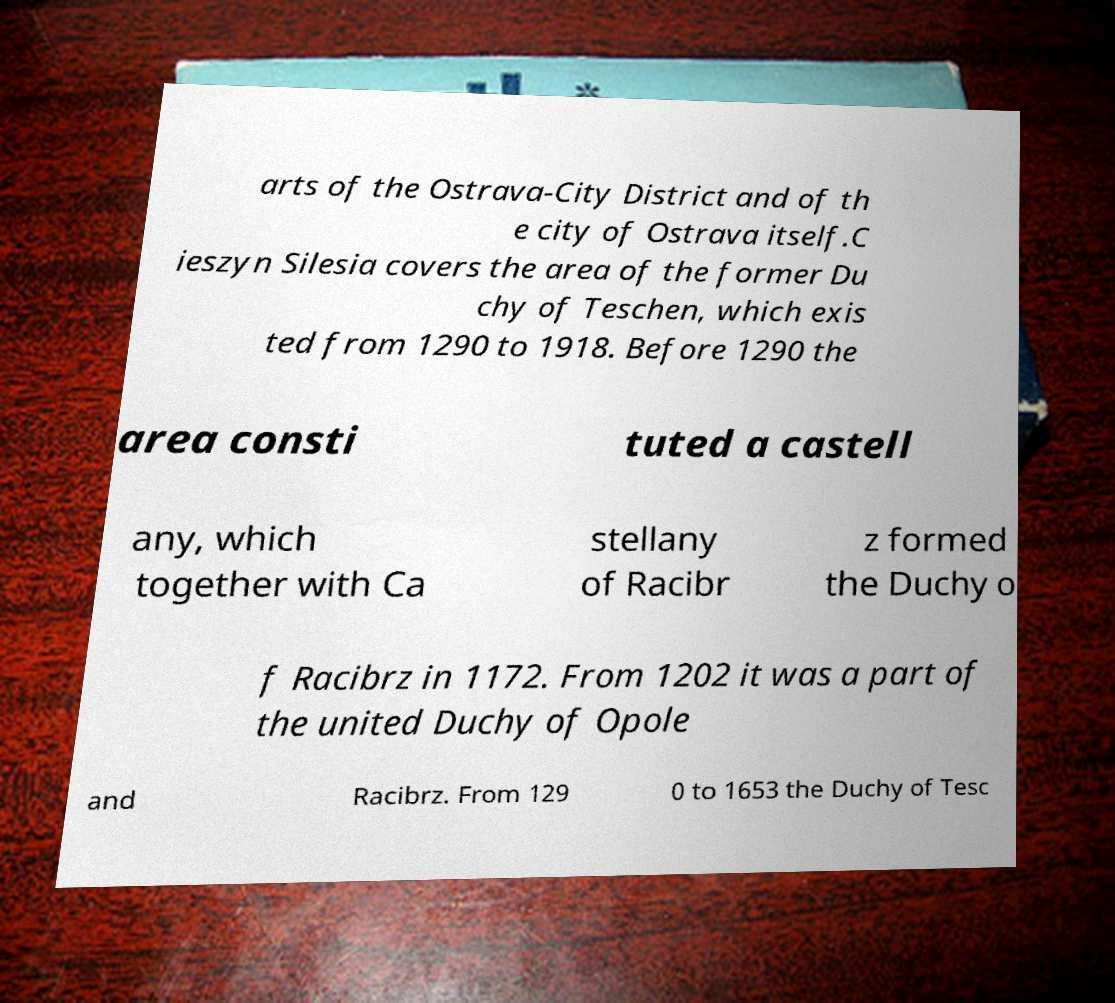Please read and relay the text visible in this image. What does it say? arts of the Ostrava-City District and of th e city of Ostrava itself.C ieszyn Silesia covers the area of the former Du chy of Teschen, which exis ted from 1290 to 1918. Before 1290 the area consti tuted a castell any, which together with Ca stellany of Racibr z formed the Duchy o f Racibrz in 1172. From 1202 it was a part of the united Duchy of Opole and Racibrz. From 129 0 to 1653 the Duchy of Tesc 